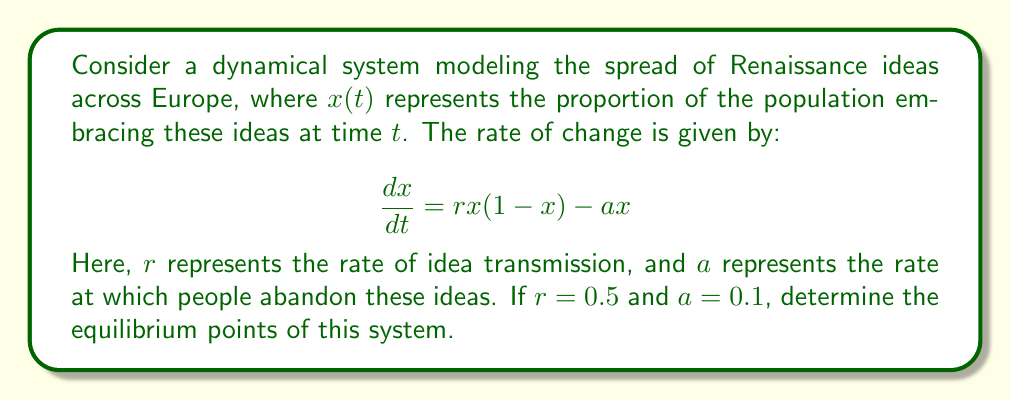Help me with this question. To find the equilibrium points, we set the rate of change equal to zero:

$$\frac{dx}{dt} = 0$$

Substituting the equation:

$$0.5x(1-x) - 0.1x = 0$$

Factoring out $x$:

$$x(0.5(1-x) - 0.1) = 0$$

$$x(0.5 - 0.5x - 0.1) = 0$$

$$x(0.4 - 0.5x) = 0$$

This equation is satisfied when either $x = 0$ or $0.4 - 0.5x = 0$

For the second case:
$$0.4 - 0.5x = 0$$
$$-0.5x = -0.4$$
$$x = 0.8$$

Therefore, the equilibrium points are $x = 0$ and $x = 0.8$.

Historically, $x = 0$ represents the state before the Renaissance ideas spread, while $x = 0.8$ represents a state where 80% of the population has embraced Renaissance thinking.
Answer: $x = 0$ and $x = 0.8$ 